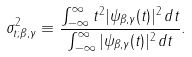<formula> <loc_0><loc_0><loc_500><loc_500>\sigma _ { t ; \beta , \gamma } ^ { 2 } \equiv \frac { \int _ { - \infty } ^ { \infty } t ^ { 2 } | \psi _ { \beta , \gamma } ( t ) | ^ { 2 } \, d t } { \int _ { - \infty } ^ { \infty } | \psi _ { \beta , \gamma } ( t ) | ^ { 2 } \, d t } .</formula> 